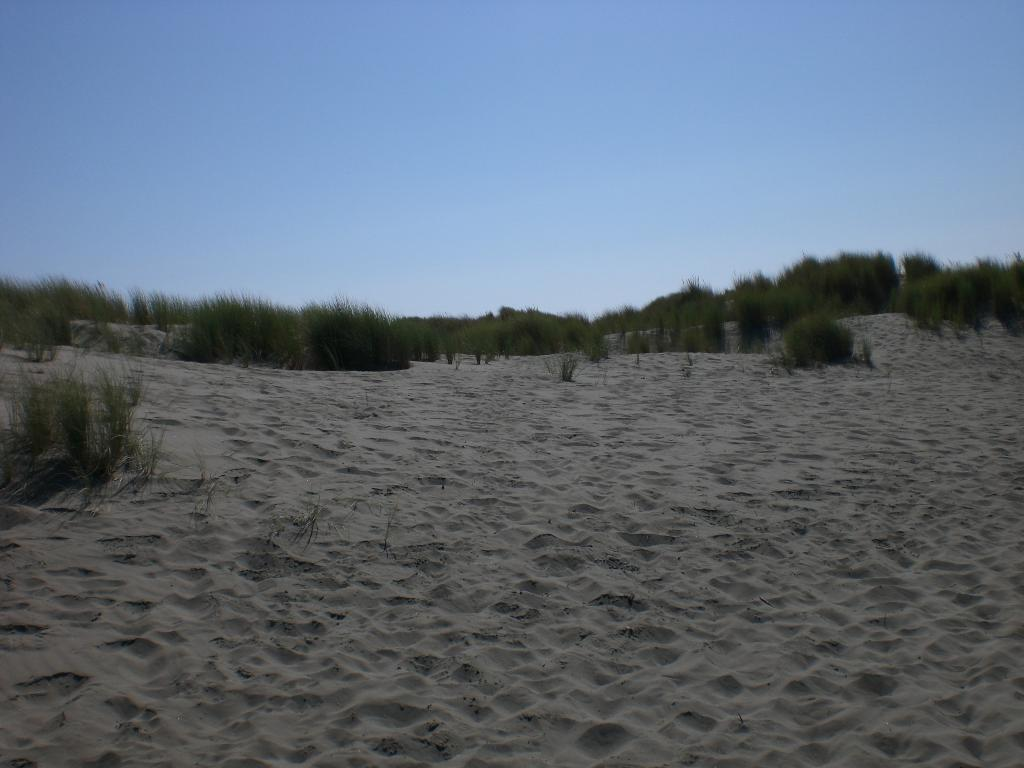What type of terrain is visible in the image? There is sand and grass visible in the image. What can be seen in the background of the image? There are trees in the background of the image. What part of the natural environment is visible in the image? The sky is visible in the image. What advice does the grandfather give to the child in the image? There is no grandfather or child present in the image, so it is not possible to answer that question. 